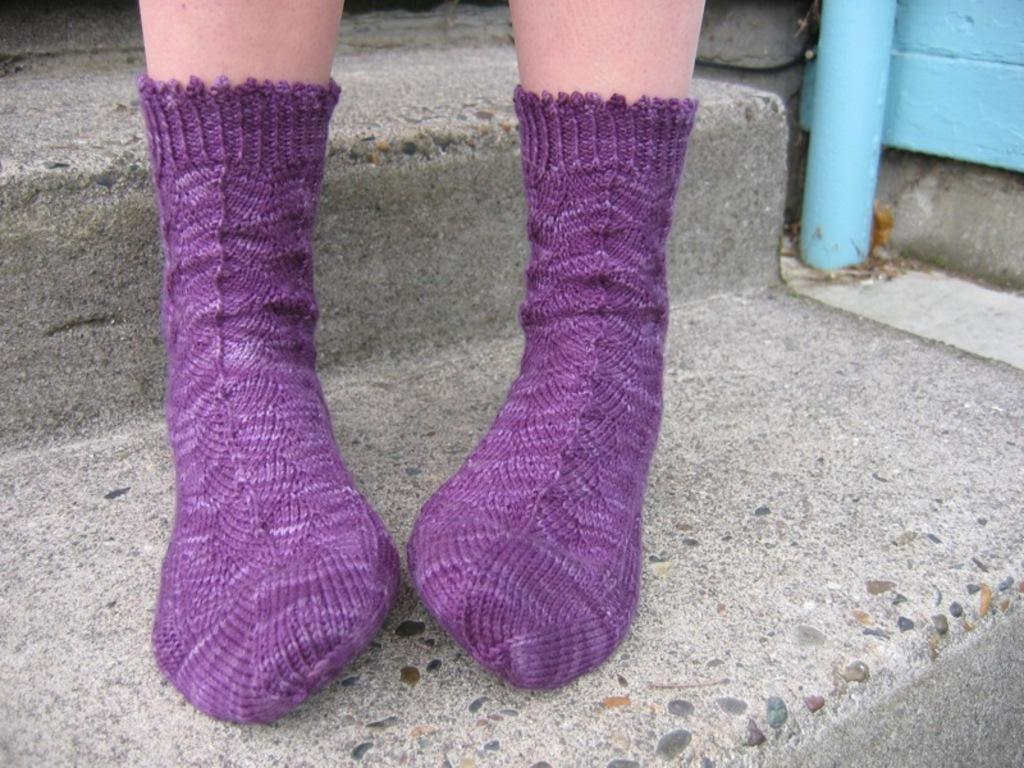What is the main focus of the image? The main focus of the image is the legs of a person wearing socks. What can be seen in the background of the image? There are stairs visible in the background of the image, as well as other unspecified objects. What type of coat is the person wearing in the image? There is no coat visible in the image; only the legs of a person wearing socks are shown. 